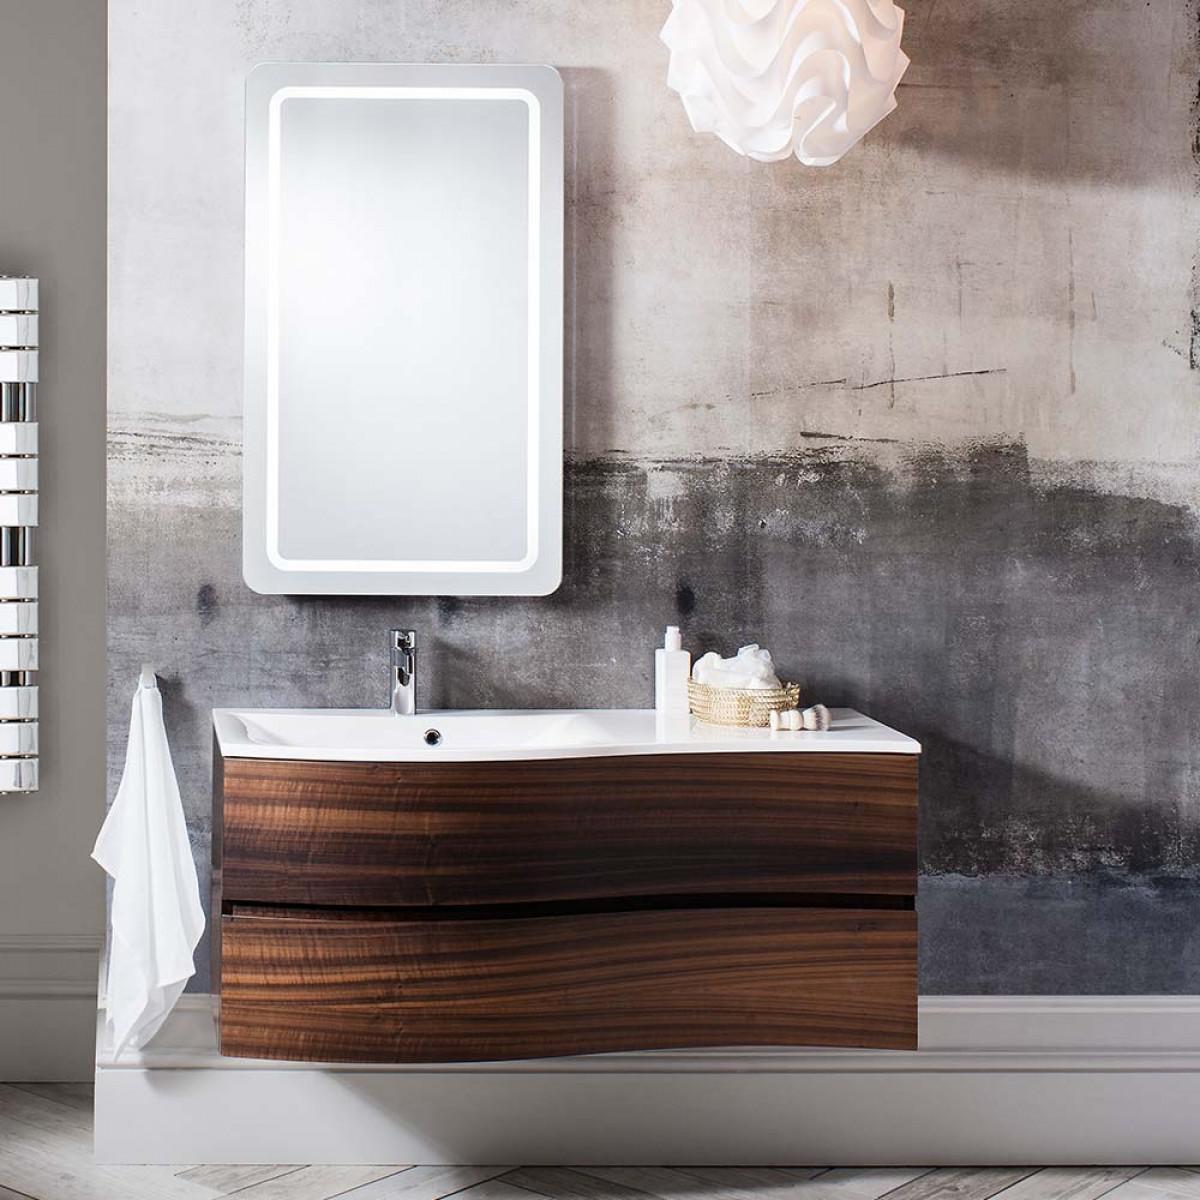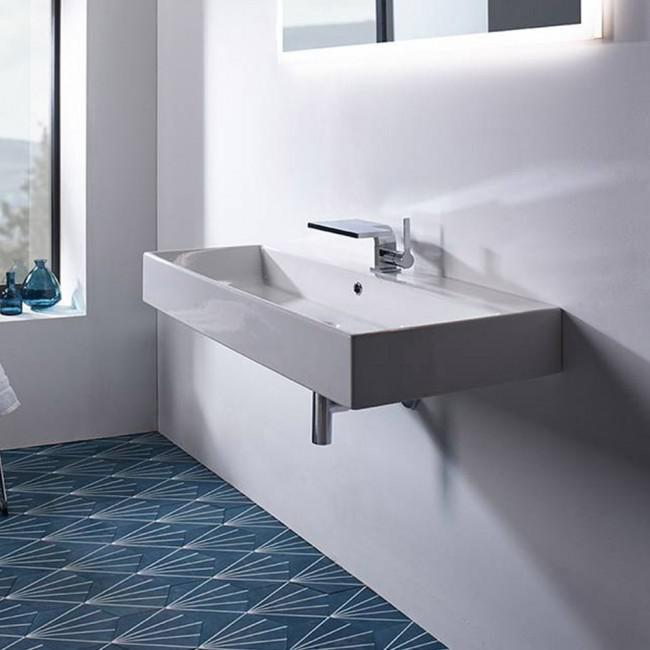The first image is the image on the left, the second image is the image on the right. For the images displayed, is the sentence "At least one of the sinks has a floral arrangement next to it." factually correct? Answer yes or no. No. 